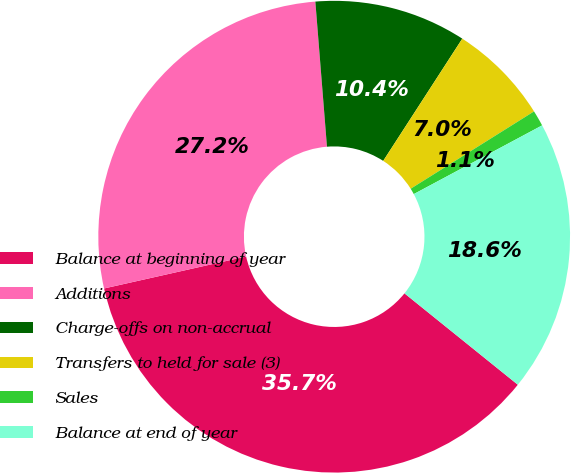Convert chart to OTSL. <chart><loc_0><loc_0><loc_500><loc_500><pie_chart><fcel>Balance at beginning of year<fcel>Additions<fcel>Charge-offs on non-accrual<fcel>Transfers to held for sale (3)<fcel>Sales<fcel>Balance at end of year<nl><fcel>35.68%<fcel>27.25%<fcel>10.41%<fcel>6.95%<fcel>1.09%<fcel>18.62%<nl></chart> 